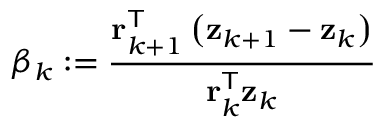<formula> <loc_0><loc_0><loc_500><loc_500>\beta _ { k } \colon = { \frac { r _ { k + 1 } ^ { T } \left ( z _ { k + 1 } - z _ { k } \right ) } { r _ { k } ^ { T } z _ { k } } }</formula> 